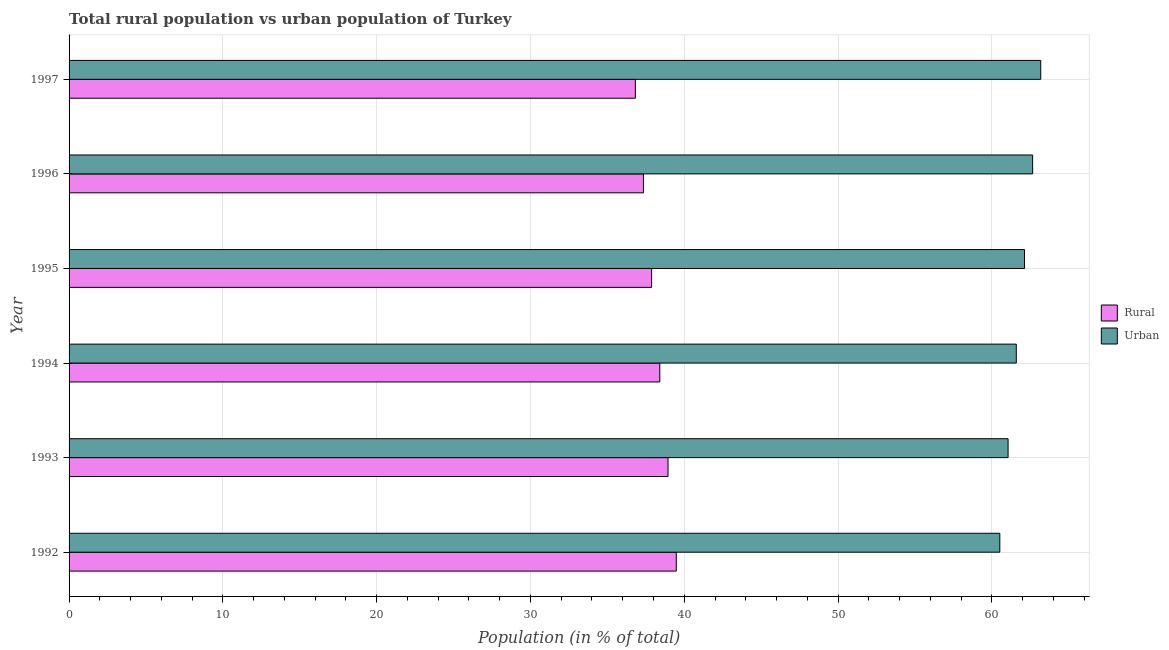Are the number of bars per tick equal to the number of legend labels?
Your answer should be compact. Yes. Are the number of bars on each tick of the Y-axis equal?
Offer a very short reply. Yes. How many bars are there on the 6th tick from the top?
Give a very brief answer. 2. How many bars are there on the 2nd tick from the bottom?
Your response must be concise. 2. What is the label of the 6th group of bars from the top?
Your answer should be very brief. 1992. What is the rural population in 1994?
Your response must be concise. 38.41. Across all years, what is the maximum urban population?
Offer a very short reply. 63.18. Across all years, what is the minimum rural population?
Ensure brevity in your answer.  36.82. What is the total urban population in the graph?
Provide a succinct answer. 371.12. What is the difference between the rural population in 1993 and that in 1994?
Offer a very short reply. 0.54. What is the difference between the urban population in 1995 and the rural population in 1994?
Provide a succinct answer. 23.71. What is the average urban population per year?
Give a very brief answer. 61.85. In the year 1995, what is the difference between the urban population and rural population?
Offer a very short reply. 24.25. In how many years, is the urban population greater than 34 %?
Make the answer very short. 6. What is the ratio of the rural population in 1994 to that in 1997?
Your response must be concise. 1.04. Is the urban population in 1992 less than that in 1993?
Give a very brief answer. Yes. What is the difference between the highest and the second highest urban population?
Offer a very short reply. 0.53. What is the difference between the highest and the lowest rural population?
Your answer should be very brief. 2.66. Is the sum of the rural population in 1992 and 1996 greater than the maximum urban population across all years?
Offer a very short reply. Yes. What does the 2nd bar from the top in 1996 represents?
Offer a very short reply. Rural. What does the 2nd bar from the bottom in 1994 represents?
Offer a terse response. Urban. How many bars are there?
Provide a succinct answer. 12. Are all the bars in the graph horizontal?
Your response must be concise. Yes. How many years are there in the graph?
Give a very brief answer. 6. What is the difference between two consecutive major ticks on the X-axis?
Make the answer very short. 10. Does the graph contain grids?
Your answer should be compact. Yes. Where does the legend appear in the graph?
Offer a very short reply. Center right. How many legend labels are there?
Provide a short and direct response. 2. How are the legend labels stacked?
Make the answer very short. Vertical. What is the title of the graph?
Your response must be concise. Total rural population vs urban population of Turkey. Does "From human activities" appear as one of the legend labels in the graph?
Provide a succinct answer. No. What is the label or title of the X-axis?
Ensure brevity in your answer.  Population (in % of total). What is the label or title of the Y-axis?
Ensure brevity in your answer.  Year. What is the Population (in % of total) of Rural in 1992?
Provide a short and direct response. 39.48. What is the Population (in % of total) of Urban in 1992?
Offer a terse response. 60.52. What is the Population (in % of total) in Rural in 1993?
Keep it short and to the point. 38.95. What is the Population (in % of total) in Urban in 1993?
Provide a short and direct response. 61.05. What is the Population (in % of total) in Rural in 1994?
Your answer should be very brief. 38.41. What is the Population (in % of total) of Urban in 1994?
Offer a very short reply. 61.59. What is the Population (in % of total) in Rural in 1995?
Provide a short and direct response. 37.88. What is the Population (in % of total) of Urban in 1995?
Offer a very short reply. 62.12. What is the Population (in % of total) of Rural in 1996?
Your answer should be very brief. 37.35. What is the Population (in % of total) in Urban in 1996?
Keep it short and to the point. 62.65. What is the Population (in % of total) of Rural in 1997?
Offer a terse response. 36.82. What is the Population (in % of total) in Urban in 1997?
Give a very brief answer. 63.18. Across all years, what is the maximum Population (in % of total) of Rural?
Make the answer very short. 39.48. Across all years, what is the maximum Population (in % of total) of Urban?
Your answer should be very brief. 63.18. Across all years, what is the minimum Population (in % of total) in Rural?
Your answer should be compact. 36.82. Across all years, what is the minimum Population (in % of total) of Urban?
Offer a very short reply. 60.52. What is the total Population (in % of total) in Rural in the graph?
Give a very brief answer. 228.88. What is the total Population (in % of total) in Urban in the graph?
Offer a terse response. 371.12. What is the difference between the Population (in % of total) in Rural in 1992 and that in 1993?
Keep it short and to the point. 0.54. What is the difference between the Population (in % of total) of Urban in 1992 and that in 1993?
Give a very brief answer. -0.54. What is the difference between the Population (in % of total) of Rural in 1992 and that in 1994?
Your answer should be compact. 1.07. What is the difference between the Population (in % of total) in Urban in 1992 and that in 1994?
Make the answer very short. -1.07. What is the difference between the Population (in % of total) in Rural in 1992 and that in 1995?
Keep it short and to the point. 1.6. What is the difference between the Population (in % of total) in Urban in 1992 and that in 1995?
Keep it short and to the point. -1.6. What is the difference between the Population (in % of total) in Rural in 1992 and that in 1996?
Make the answer very short. 2.13. What is the difference between the Population (in % of total) in Urban in 1992 and that in 1996?
Ensure brevity in your answer.  -2.13. What is the difference between the Population (in % of total) of Rural in 1992 and that in 1997?
Provide a succinct answer. 2.66. What is the difference between the Population (in % of total) in Urban in 1992 and that in 1997?
Keep it short and to the point. -2.66. What is the difference between the Population (in % of total) of Rural in 1993 and that in 1994?
Your response must be concise. 0.54. What is the difference between the Population (in % of total) of Urban in 1993 and that in 1994?
Ensure brevity in your answer.  -0.54. What is the difference between the Population (in % of total) in Rural in 1993 and that in 1995?
Your response must be concise. 1.07. What is the difference between the Population (in % of total) in Urban in 1993 and that in 1995?
Offer a very short reply. -1.07. What is the difference between the Population (in % of total) of Rural in 1993 and that in 1996?
Your answer should be compact. 1.6. What is the difference between the Population (in % of total) in Urban in 1993 and that in 1996?
Your answer should be compact. -1.6. What is the difference between the Population (in % of total) of Rural in 1993 and that in 1997?
Your answer should be very brief. 2.12. What is the difference between the Population (in % of total) of Urban in 1993 and that in 1997?
Give a very brief answer. -2.12. What is the difference between the Population (in % of total) of Rural in 1994 and that in 1995?
Keep it short and to the point. 0.53. What is the difference between the Population (in % of total) of Urban in 1994 and that in 1995?
Your answer should be very brief. -0.53. What is the difference between the Population (in % of total) of Rural in 1994 and that in 1996?
Ensure brevity in your answer.  1.06. What is the difference between the Population (in % of total) of Urban in 1994 and that in 1996?
Provide a short and direct response. -1.06. What is the difference between the Population (in % of total) in Rural in 1994 and that in 1997?
Make the answer very short. 1.59. What is the difference between the Population (in % of total) in Urban in 1994 and that in 1997?
Offer a very short reply. -1.59. What is the difference between the Population (in % of total) of Rural in 1995 and that in 1996?
Provide a short and direct response. 0.53. What is the difference between the Population (in % of total) in Urban in 1995 and that in 1996?
Keep it short and to the point. -0.53. What is the difference between the Population (in % of total) of Rural in 1995 and that in 1997?
Provide a short and direct response. 1.06. What is the difference between the Population (in % of total) of Urban in 1995 and that in 1997?
Your answer should be very brief. -1.06. What is the difference between the Population (in % of total) in Rural in 1996 and that in 1997?
Offer a very short reply. 0.53. What is the difference between the Population (in % of total) in Urban in 1996 and that in 1997?
Ensure brevity in your answer.  -0.53. What is the difference between the Population (in % of total) in Rural in 1992 and the Population (in % of total) in Urban in 1993?
Your response must be concise. -21.57. What is the difference between the Population (in % of total) of Rural in 1992 and the Population (in % of total) of Urban in 1994?
Offer a terse response. -22.11. What is the difference between the Population (in % of total) in Rural in 1992 and the Population (in % of total) in Urban in 1995?
Provide a succinct answer. -22.64. What is the difference between the Population (in % of total) in Rural in 1992 and the Population (in % of total) in Urban in 1996?
Ensure brevity in your answer.  -23.17. What is the difference between the Population (in % of total) in Rural in 1992 and the Population (in % of total) in Urban in 1997?
Ensure brevity in your answer.  -23.7. What is the difference between the Population (in % of total) of Rural in 1993 and the Population (in % of total) of Urban in 1994?
Offer a terse response. -22.64. What is the difference between the Population (in % of total) in Rural in 1993 and the Population (in % of total) in Urban in 1995?
Offer a terse response. -23.18. What is the difference between the Population (in % of total) in Rural in 1993 and the Population (in % of total) in Urban in 1996?
Give a very brief answer. -23.71. What is the difference between the Population (in % of total) in Rural in 1993 and the Population (in % of total) in Urban in 1997?
Ensure brevity in your answer.  -24.23. What is the difference between the Population (in % of total) of Rural in 1994 and the Population (in % of total) of Urban in 1995?
Ensure brevity in your answer.  -23.71. What is the difference between the Population (in % of total) of Rural in 1994 and the Population (in % of total) of Urban in 1996?
Provide a short and direct response. -24.24. What is the difference between the Population (in % of total) in Rural in 1994 and the Population (in % of total) in Urban in 1997?
Provide a short and direct response. -24.77. What is the difference between the Population (in % of total) in Rural in 1995 and the Population (in % of total) in Urban in 1996?
Keep it short and to the point. -24.78. What is the difference between the Population (in % of total) of Rural in 1995 and the Population (in % of total) of Urban in 1997?
Ensure brevity in your answer.  -25.3. What is the difference between the Population (in % of total) in Rural in 1996 and the Population (in % of total) in Urban in 1997?
Offer a very short reply. -25.83. What is the average Population (in % of total) in Rural per year?
Offer a terse response. 38.15. What is the average Population (in % of total) in Urban per year?
Offer a terse response. 61.85. In the year 1992, what is the difference between the Population (in % of total) in Rural and Population (in % of total) in Urban?
Offer a terse response. -21.04. In the year 1993, what is the difference between the Population (in % of total) in Rural and Population (in % of total) in Urban?
Your answer should be very brief. -22.11. In the year 1994, what is the difference between the Population (in % of total) in Rural and Population (in % of total) in Urban?
Provide a succinct answer. -23.18. In the year 1995, what is the difference between the Population (in % of total) in Rural and Population (in % of total) in Urban?
Your answer should be very brief. -24.25. In the year 1996, what is the difference between the Population (in % of total) in Rural and Population (in % of total) in Urban?
Keep it short and to the point. -25.31. In the year 1997, what is the difference between the Population (in % of total) in Rural and Population (in % of total) in Urban?
Your response must be concise. -26.36. What is the ratio of the Population (in % of total) of Rural in 1992 to that in 1993?
Keep it short and to the point. 1.01. What is the ratio of the Population (in % of total) of Urban in 1992 to that in 1993?
Ensure brevity in your answer.  0.99. What is the ratio of the Population (in % of total) of Rural in 1992 to that in 1994?
Ensure brevity in your answer.  1.03. What is the ratio of the Population (in % of total) of Urban in 1992 to that in 1994?
Make the answer very short. 0.98. What is the ratio of the Population (in % of total) in Rural in 1992 to that in 1995?
Provide a short and direct response. 1.04. What is the ratio of the Population (in % of total) of Urban in 1992 to that in 1995?
Give a very brief answer. 0.97. What is the ratio of the Population (in % of total) of Rural in 1992 to that in 1996?
Offer a very short reply. 1.06. What is the ratio of the Population (in % of total) in Urban in 1992 to that in 1996?
Keep it short and to the point. 0.97. What is the ratio of the Population (in % of total) in Rural in 1992 to that in 1997?
Provide a short and direct response. 1.07. What is the ratio of the Population (in % of total) in Urban in 1992 to that in 1997?
Keep it short and to the point. 0.96. What is the ratio of the Population (in % of total) in Rural in 1993 to that in 1994?
Make the answer very short. 1.01. What is the ratio of the Population (in % of total) of Urban in 1993 to that in 1994?
Your answer should be compact. 0.99. What is the ratio of the Population (in % of total) of Rural in 1993 to that in 1995?
Ensure brevity in your answer.  1.03. What is the ratio of the Population (in % of total) of Urban in 1993 to that in 1995?
Your answer should be compact. 0.98. What is the ratio of the Population (in % of total) in Rural in 1993 to that in 1996?
Provide a short and direct response. 1.04. What is the ratio of the Population (in % of total) of Urban in 1993 to that in 1996?
Offer a very short reply. 0.97. What is the ratio of the Population (in % of total) of Rural in 1993 to that in 1997?
Ensure brevity in your answer.  1.06. What is the ratio of the Population (in % of total) in Urban in 1993 to that in 1997?
Your answer should be compact. 0.97. What is the ratio of the Population (in % of total) of Rural in 1994 to that in 1995?
Provide a succinct answer. 1.01. What is the ratio of the Population (in % of total) of Urban in 1994 to that in 1995?
Your answer should be compact. 0.99. What is the ratio of the Population (in % of total) in Rural in 1994 to that in 1996?
Your answer should be compact. 1.03. What is the ratio of the Population (in % of total) in Urban in 1994 to that in 1996?
Give a very brief answer. 0.98. What is the ratio of the Population (in % of total) in Rural in 1994 to that in 1997?
Your response must be concise. 1.04. What is the ratio of the Population (in % of total) of Urban in 1994 to that in 1997?
Offer a very short reply. 0.97. What is the ratio of the Population (in % of total) of Rural in 1995 to that in 1996?
Your response must be concise. 1.01. What is the ratio of the Population (in % of total) in Rural in 1995 to that in 1997?
Your answer should be compact. 1.03. What is the ratio of the Population (in % of total) in Urban in 1995 to that in 1997?
Your answer should be compact. 0.98. What is the ratio of the Population (in % of total) in Rural in 1996 to that in 1997?
Your answer should be very brief. 1.01. What is the difference between the highest and the second highest Population (in % of total) in Rural?
Ensure brevity in your answer.  0.54. What is the difference between the highest and the second highest Population (in % of total) of Urban?
Offer a very short reply. 0.53. What is the difference between the highest and the lowest Population (in % of total) of Rural?
Keep it short and to the point. 2.66. What is the difference between the highest and the lowest Population (in % of total) in Urban?
Your response must be concise. 2.66. 